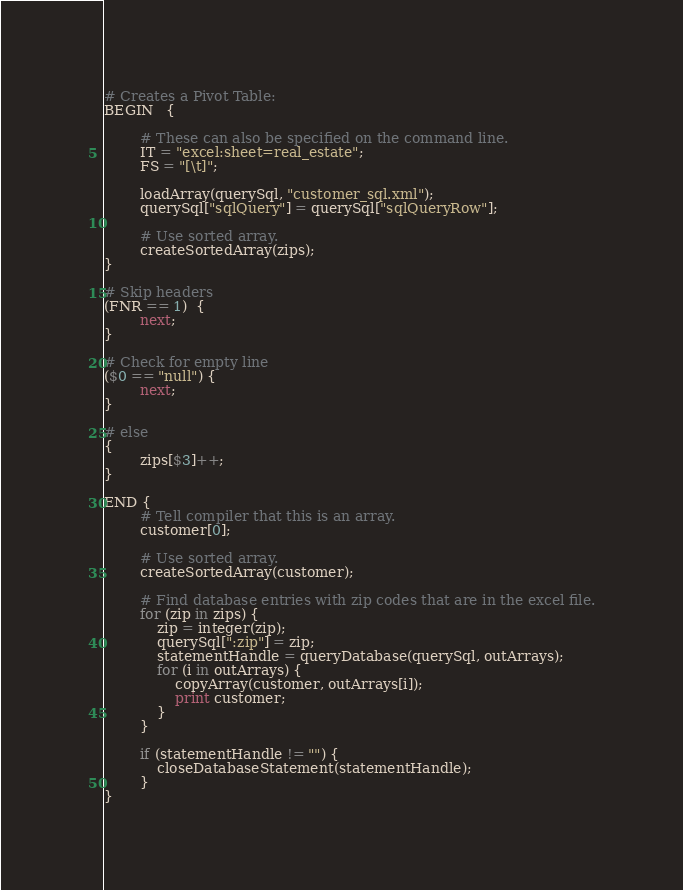Convert code to text. <code><loc_0><loc_0><loc_500><loc_500><_Awk_># Creates a Pivot Table:
BEGIN   {

        # These can also be specified on the command line.
        IT = "excel:sheet=real_estate";
        FS = "[\t]"; 

        loadArray(querySql, "customer_sql.xml");
        querySql["sqlQuery"] = querySql["sqlQueryRow"];
        
        # Use sorted array.
        createSortedArray(zips);
}

# Skip headers
(FNR == 1)  {
        next;
}

# Check for empty line
($0 == "null") {
        next;
}

# else
{
        zips[$3]++;
}

END {
        # Tell compiler that this is an array.
        customer[0];
        
        # Use sorted array.
        createSortedArray(customer);

        # Find database entries with zip codes that are in the excel file.
        for (zip in zips) {
            zip = integer(zip);
            querySql[":zip"] = zip;
            statementHandle = queryDatabase(querySql, outArrays);
            for (i in outArrays) {
                copyArray(customer, outArrays[i]);
                print customer;
            }
        }

        if (statementHandle != "") {
            closeDatabaseStatement(statementHandle);
        }
}
</code> 